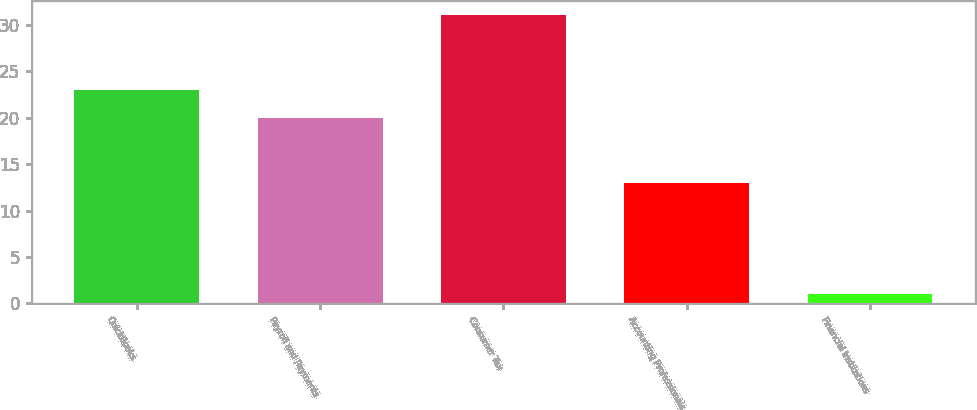Convert chart to OTSL. <chart><loc_0><loc_0><loc_500><loc_500><bar_chart><fcel>QuickBooks<fcel>Payroll and Payments<fcel>Consumer Tax<fcel>Accounting Professionals<fcel>Financial Institutions<nl><fcel>23<fcel>20<fcel>31<fcel>13<fcel>1<nl></chart> 